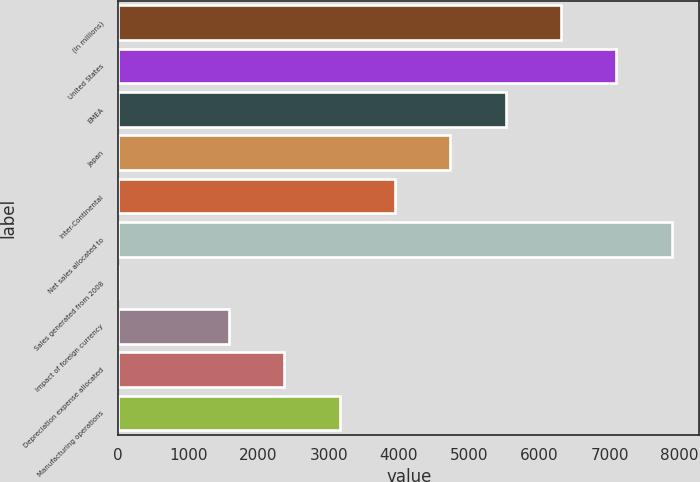Convert chart. <chart><loc_0><loc_0><loc_500><loc_500><bar_chart><fcel>(in millions)<fcel>United States<fcel>EMEA<fcel>Japan<fcel>Inter-Continental<fcel>Net sales allocated to<fcel>Sales generated from 2008<fcel>Impact of foreign currency<fcel>Depreciation expense allocated<fcel>Manufacturing operations<nl><fcel>6307.2<fcel>7095.1<fcel>5519.3<fcel>4731.4<fcel>3943.5<fcel>7883<fcel>4<fcel>1579.8<fcel>2367.7<fcel>3155.6<nl></chart> 